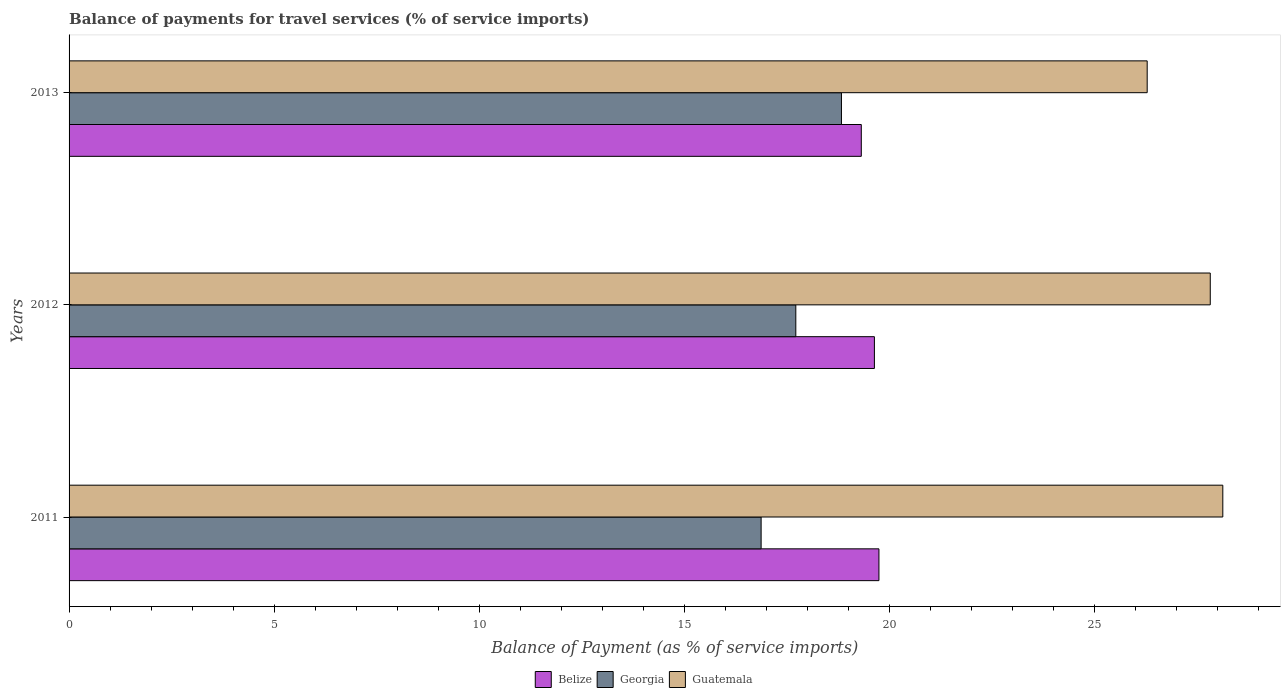How many different coloured bars are there?
Offer a very short reply. 3. How many groups of bars are there?
Offer a terse response. 3. How many bars are there on the 2nd tick from the top?
Ensure brevity in your answer.  3. How many bars are there on the 3rd tick from the bottom?
Provide a succinct answer. 3. What is the label of the 3rd group of bars from the top?
Your response must be concise. 2011. What is the balance of payments for travel services in Guatemala in 2012?
Your answer should be compact. 27.82. Across all years, what is the maximum balance of payments for travel services in Belize?
Provide a succinct answer. 19.74. Across all years, what is the minimum balance of payments for travel services in Guatemala?
Your response must be concise. 26.28. In which year was the balance of payments for travel services in Belize minimum?
Your answer should be compact. 2013. What is the total balance of payments for travel services in Georgia in the graph?
Provide a succinct answer. 53.41. What is the difference between the balance of payments for travel services in Belize in 2012 and that in 2013?
Provide a succinct answer. 0.32. What is the difference between the balance of payments for travel services in Belize in 2011 and the balance of payments for travel services in Guatemala in 2012?
Offer a terse response. -8.08. What is the average balance of payments for travel services in Georgia per year?
Provide a short and direct response. 17.8. In the year 2013, what is the difference between the balance of payments for travel services in Belize and balance of payments for travel services in Guatemala?
Keep it short and to the point. -6.97. In how many years, is the balance of payments for travel services in Belize greater than 18 %?
Offer a terse response. 3. What is the ratio of the balance of payments for travel services in Georgia in 2011 to that in 2013?
Offer a terse response. 0.9. Is the difference between the balance of payments for travel services in Belize in 2012 and 2013 greater than the difference between the balance of payments for travel services in Guatemala in 2012 and 2013?
Your answer should be very brief. No. What is the difference between the highest and the second highest balance of payments for travel services in Belize?
Provide a succinct answer. 0.11. What is the difference between the highest and the lowest balance of payments for travel services in Guatemala?
Ensure brevity in your answer.  1.84. In how many years, is the balance of payments for travel services in Georgia greater than the average balance of payments for travel services in Georgia taken over all years?
Offer a terse response. 1. What does the 3rd bar from the top in 2012 represents?
Give a very brief answer. Belize. What does the 2nd bar from the bottom in 2013 represents?
Provide a short and direct response. Georgia. How many bars are there?
Make the answer very short. 9. Are all the bars in the graph horizontal?
Your response must be concise. Yes. What is the difference between two consecutive major ticks on the X-axis?
Provide a succinct answer. 5. Where does the legend appear in the graph?
Your answer should be very brief. Bottom center. What is the title of the graph?
Make the answer very short. Balance of payments for travel services (% of service imports). What is the label or title of the X-axis?
Provide a succinct answer. Balance of Payment (as % of service imports). What is the Balance of Payment (as % of service imports) in Belize in 2011?
Your answer should be very brief. 19.74. What is the Balance of Payment (as % of service imports) in Georgia in 2011?
Your response must be concise. 16.87. What is the Balance of Payment (as % of service imports) of Guatemala in 2011?
Give a very brief answer. 28.12. What is the Balance of Payment (as % of service imports) in Belize in 2012?
Provide a succinct answer. 19.63. What is the Balance of Payment (as % of service imports) of Georgia in 2012?
Your response must be concise. 17.71. What is the Balance of Payment (as % of service imports) in Guatemala in 2012?
Offer a terse response. 27.82. What is the Balance of Payment (as % of service imports) of Belize in 2013?
Provide a succinct answer. 19.31. What is the Balance of Payment (as % of service imports) in Georgia in 2013?
Offer a very short reply. 18.83. What is the Balance of Payment (as % of service imports) of Guatemala in 2013?
Your response must be concise. 26.28. Across all years, what is the maximum Balance of Payment (as % of service imports) of Belize?
Give a very brief answer. 19.74. Across all years, what is the maximum Balance of Payment (as % of service imports) of Georgia?
Provide a short and direct response. 18.83. Across all years, what is the maximum Balance of Payment (as % of service imports) in Guatemala?
Make the answer very short. 28.12. Across all years, what is the minimum Balance of Payment (as % of service imports) in Belize?
Your response must be concise. 19.31. Across all years, what is the minimum Balance of Payment (as % of service imports) of Georgia?
Make the answer very short. 16.87. Across all years, what is the minimum Balance of Payment (as % of service imports) in Guatemala?
Keep it short and to the point. 26.28. What is the total Balance of Payment (as % of service imports) of Belize in the graph?
Your answer should be compact. 58.68. What is the total Balance of Payment (as % of service imports) of Georgia in the graph?
Give a very brief answer. 53.41. What is the total Balance of Payment (as % of service imports) in Guatemala in the graph?
Keep it short and to the point. 82.22. What is the difference between the Balance of Payment (as % of service imports) in Belize in 2011 and that in 2012?
Offer a very short reply. 0.11. What is the difference between the Balance of Payment (as % of service imports) of Georgia in 2011 and that in 2012?
Your answer should be very brief. -0.85. What is the difference between the Balance of Payment (as % of service imports) of Guatemala in 2011 and that in 2012?
Your response must be concise. 0.31. What is the difference between the Balance of Payment (as % of service imports) of Belize in 2011 and that in 2013?
Your answer should be compact. 0.43. What is the difference between the Balance of Payment (as % of service imports) in Georgia in 2011 and that in 2013?
Ensure brevity in your answer.  -1.96. What is the difference between the Balance of Payment (as % of service imports) of Guatemala in 2011 and that in 2013?
Keep it short and to the point. 1.84. What is the difference between the Balance of Payment (as % of service imports) in Belize in 2012 and that in 2013?
Your answer should be very brief. 0.32. What is the difference between the Balance of Payment (as % of service imports) of Georgia in 2012 and that in 2013?
Provide a succinct answer. -1.11. What is the difference between the Balance of Payment (as % of service imports) in Guatemala in 2012 and that in 2013?
Provide a succinct answer. 1.54. What is the difference between the Balance of Payment (as % of service imports) of Belize in 2011 and the Balance of Payment (as % of service imports) of Georgia in 2012?
Your answer should be very brief. 2.03. What is the difference between the Balance of Payment (as % of service imports) in Belize in 2011 and the Balance of Payment (as % of service imports) in Guatemala in 2012?
Your response must be concise. -8.08. What is the difference between the Balance of Payment (as % of service imports) of Georgia in 2011 and the Balance of Payment (as % of service imports) of Guatemala in 2012?
Your response must be concise. -10.95. What is the difference between the Balance of Payment (as % of service imports) of Belize in 2011 and the Balance of Payment (as % of service imports) of Georgia in 2013?
Provide a short and direct response. 0.91. What is the difference between the Balance of Payment (as % of service imports) of Belize in 2011 and the Balance of Payment (as % of service imports) of Guatemala in 2013?
Make the answer very short. -6.54. What is the difference between the Balance of Payment (as % of service imports) in Georgia in 2011 and the Balance of Payment (as % of service imports) in Guatemala in 2013?
Give a very brief answer. -9.41. What is the difference between the Balance of Payment (as % of service imports) in Belize in 2012 and the Balance of Payment (as % of service imports) in Georgia in 2013?
Your answer should be very brief. 0.8. What is the difference between the Balance of Payment (as % of service imports) in Belize in 2012 and the Balance of Payment (as % of service imports) in Guatemala in 2013?
Offer a very short reply. -6.65. What is the difference between the Balance of Payment (as % of service imports) of Georgia in 2012 and the Balance of Payment (as % of service imports) of Guatemala in 2013?
Your answer should be very brief. -8.57. What is the average Balance of Payment (as % of service imports) of Belize per year?
Ensure brevity in your answer.  19.56. What is the average Balance of Payment (as % of service imports) of Georgia per year?
Keep it short and to the point. 17.8. What is the average Balance of Payment (as % of service imports) of Guatemala per year?
Offer a terse response. 27.41. In the year 2011, what is the difference between the Balance of Payment (as % of service imports) in Belize and Balance of Payment (as % of service imports) in Georgia?
Offer a terse response. 2.87. In the year 2011, what is the difference between the Balance of Payment (as % of service imports) in Belize and Balance of Payment (as % of service imports) in Guatemala?
Keep it short and to the point. -8.38. In the year 2011, what is the difference between the Balance of Payment (as % of service imports) of Georgia and Balance of Payment (as % of service imports) of Guatemala?
Ensure brevity in your answer.  -11.25. In the year 2012, what is the difference between the Balance of Payment (as % of service imports) in Belize and Balance of Payment (as % of service imports) in Georgia?
Your answer should be very brief. 1.92. In the year 2012, what is the difference between the Balance of Payment (as % of service imports) in Belize and Balance of Payment (as % of service imports) in Guatemala?
Keep it short and to the point. -8.19. In the year 2012, what is the difference between the Balance of Payment (as % of service imports) in Georgia and Balance of Payment (as % of service imports) in Guatemala?
Keep it short and to the point. -10.1. In the year 2013, what is the difference between the Balance of Payment (as % of service imports) of Belize and Balance of Payment (as % of service imports) of Georgia?
Offer a very short reply. 0.48. In the year 2013, what is the difference between the Balance of Payment (as % of service imports) in Belize and Balance of Payment (as % of service imports) in Guatemala?
Offer a terse response. -6.97. In the year 2013, what is the difference between the Balance of Payment (as % of service imports) of Georgia and Balance of Payment (as % of service imports) of Guatemala?
Your response must be concise. -7.45. What is the ratio of the Balance of Payment (as % of service imports) of Belize in 2011 to that in 2012?
Ensure brevity in your answer.  1.01. What is the ratio of the Balance of Payment (as % of service imports) of Georgia in 2011 to that in 2012?
Your answer should be compact. 0.95. What is the ratio of the Balance of Payment (as % of service imports) in Guatemala in 2011 to that in 2012?
Make the answer very short. 1.01. What is the ratio of the Balance of Payment (as % of service imports) in Belize in 2011 to that in 2013?
Make the answer very short. 1.02. What is the ratio of the Balance of Payment (as % of service imports) in Georgia in 2011 to that in 2013?
Give a very brief answer. 0.9. What is the ratio of the Balance of Payment (as % of service imports) of Guatemala in 2011 to that in 2013?
Provide a short and direct response. 1.07. What is the ratio of the Balance of Payment (as % of service imports) in Belize in 2012 to that in 2013?
Provide a succinct answer. 1.02. What is the ratio of the Balance of Payment (as % of service imports) in Georgia in 2012 to that in 2013?
Make the answer very short. 0.94. What is the ratio of the Balance of Payment (as % of service imports) in Guatemala in 2012 to that in 2013?
Provide a succinct answer. 1.06. What is the difference between the highest and the second highest Balance of Payment (as % of service imports) in Belize?
Your response must be concise. 0.11. What is the difference between the highest and the second highest Balance of Payment (as % of service imports) in Georgia?
Give a very brief answer. 1.11. What is the difference between the highest and the second highest Balance of Payment (as % of service imports) of Guatemala?
Keep it short and to the point. 0.31. What is the difference between the highest and the lowest Balance of Payment (as % of service imports) of Belize?
Offer a terse response. 0.43. What is the difference between the highest and the lowest Balance of Payment (as % of service imports) in Georgia?
Provide a succinct answer. 1.96. What is the difference between the highest and the lowest Balance of Payment (as % of service imports) in Guatemala?
Your answer should be compact. 1.84. 